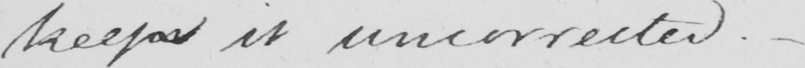Can you tell me what this handwritten text says? keeps it uncorrected .  _ 